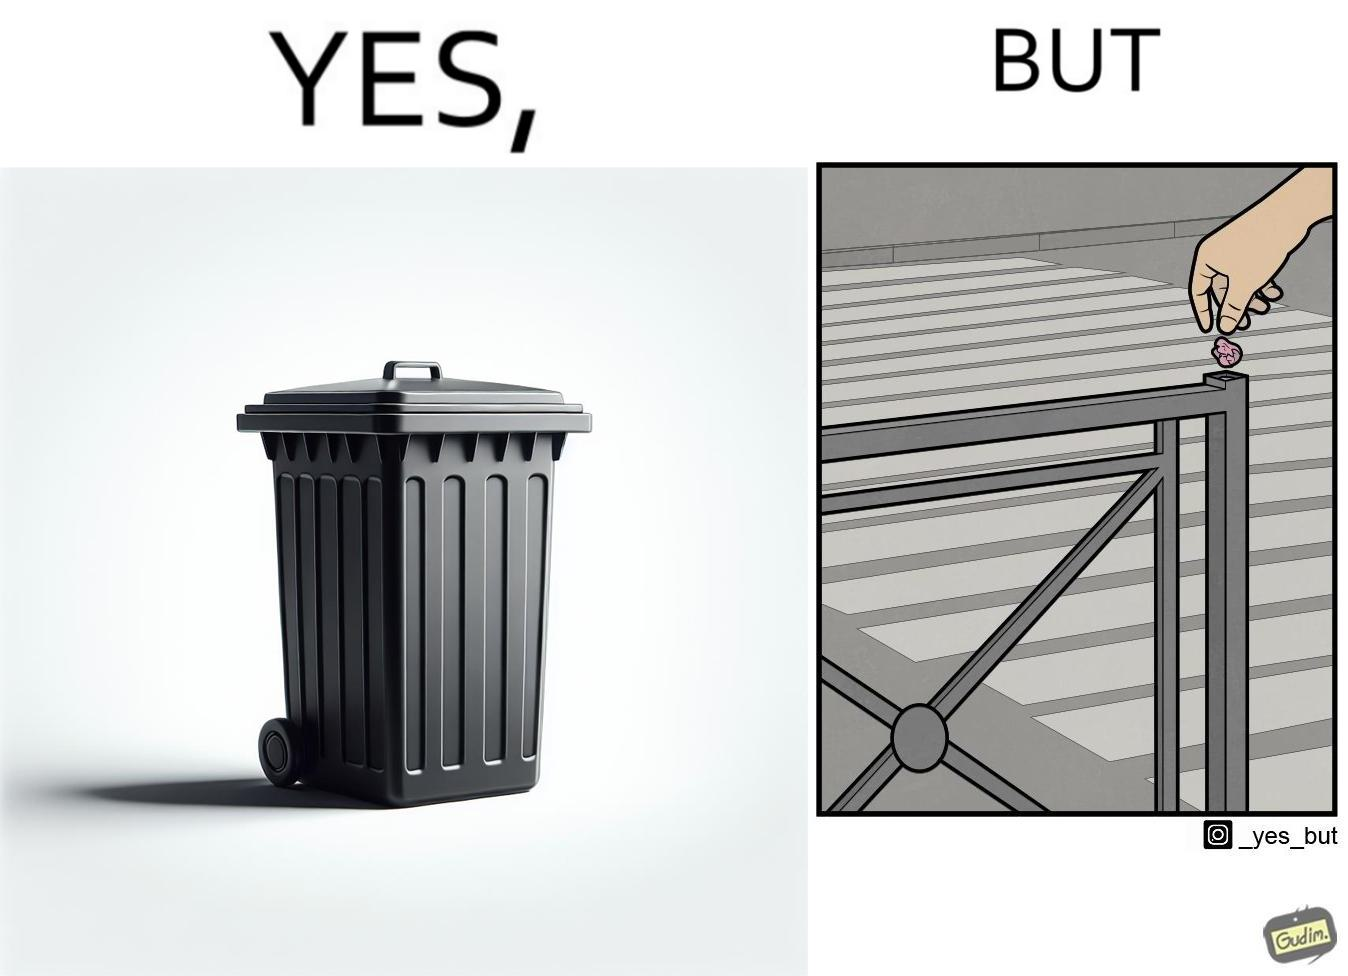What makes this image funny or satirical? The images are ironic because even though garbage bins are provided for humans to dispose waste, by habit humans still choose to make surroundings dirty by disposing garbage improperly 